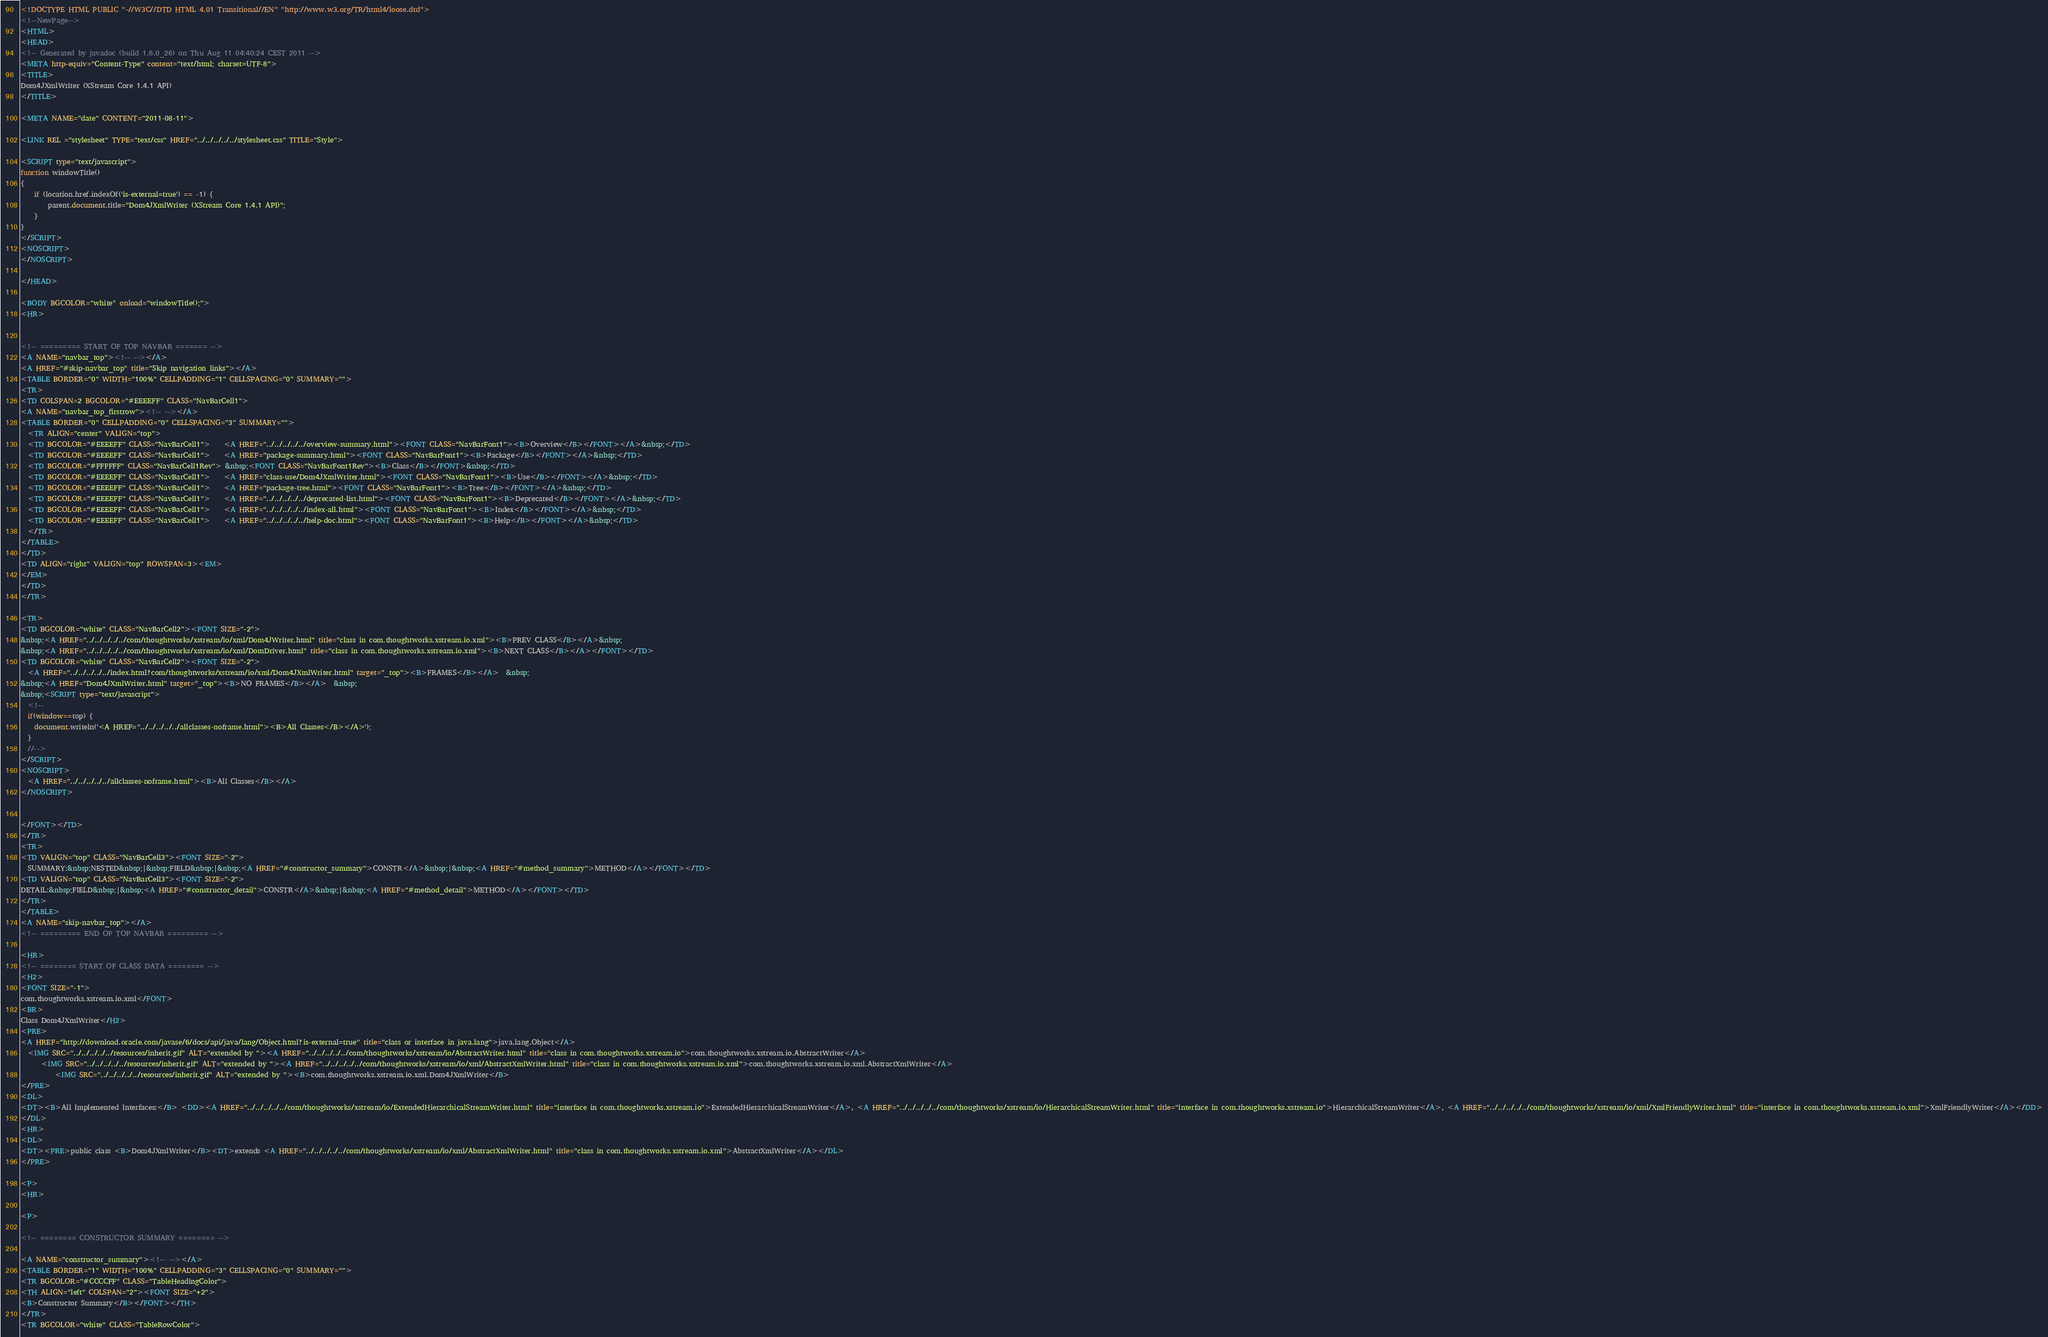Convert code to text. <code><loc_0><loc_0><loc_500><loc_500><_HTML_><!DOCTYPE HTML PUBLIC "-//W3C//DTD HTML 4.01 Transitional//EN" "http://www.w3.org/TR/html4/loose.dtd">
<!--NewPage-->
<HTML>
<HEAD>
<!-- Generated by javadoc (build 1.6.0_26) on Thu Aug 11 04:40:24 CEST 2011 -->
<META http-equiv="Content-Type" content="text/html; charset=UTF-8">
<TITLE>
Dom4JXmlWriter (XStream Core 1.4.1 API)
</TITLE>

<META NAME="date" CONTENT="2011-08-11">

<LINK REL ="stylesheet" TYPE="text/css" HREF="../../../../../stylesheet.css" TITLE="Style">

<SCRIPT type="text/javascript">
function windowTitle()
{
    if (location.href.indexOf('is-external=true') == -1) {
        parent.document.title="Dom4JXmlWriter (XStream Core 1.4.1 API)";
    }
}
</SCRIPT>
<NOSCRIPT>
</NOSCRIPT>

</HEAD>

<BODY BGCOLOR="white" onload="windowTitle();">
<HR>


<!-- ========= START OF TOP NAVBAR ======= -->
<A NAME="navbar_top"><!-- --></A>
<A HREF="#skip-navbar_top" title="Skip navigation links"></A>
<TABLE BORDER="0" WIDTH="100%" CELLPADDING="1" CELLSPACING="0" SUMMARY="">
<TR>
<TD COLSPAN=2 BGCOLOR="#EEEEFF" CLASS="NavBarCell1">
<A NAME="navbar_top_firstrow"><!-- --></A>
<TABLE BORDER="0" CELLPADDING="0" CELLSPACING="3" SUMMARY="">
  <TR ALIGN="center" VALIGN="top">
  <TD BGCOLOR="#EEEEFF" CLASS="NavBarCell1">    <A HREF="../../../../../overview-summary.html"><FONT CLASS="NavBarFont1"><B>Overview</B></FONT></A>&nbsp;</TD>
  <TD BGCOLOR="#EEEEFF" CLASS="NavBarCell1">    <A HREF="package-summary.html"><FONT CLASS="NavBarFont1"><B>Package</B></FONT></A>&nbsp;</TD>
  <TD BGCOLOR="#FFFFFF" CLASS="NavBarCell1Rev"> &nbsp;<FONT CLASS="NavBarFont1Rev"><B>Class</B></FONT>&nbsp;</TD>
  <TD BGCOLOR="#EEEEFF" CLASS="NavBarCell1">    <A HREF="class-use/Dom4JXmlWriter.html"><FONT CLASS="NavBarFont1"><B>Use</B></FONT></A>&nbsp;</TD>
  <TD BGCOLOR="#EEEEFF" CLASS="NavBarCell1">    <A HREF="package-tree.html"><FONT CLASS="NavBarFont1"><B>Tree</B></FONT></A>&nbsp;</TD>
  <TD BGCOLOR="#EEEEFF" CLASS="NavBarCell1">    <A HREF="../../../../../deprecated-list.html"><FONT CLASS="NavBarFont1"><B>Deprecated</B></FONT></A>&nbsp;</TD>
  <TD BGCOLOR="#EEEEFF" CLASS="NavBarCell1">    <A HREF="../../../../../index-all.html"><FONT CLASS="NavBarFont1"><B>Index</B></FONT></A>&nbsp;</TD>
  <TD BGCOLOR="#EEEEFF" CLASS="NavBarCell1">    <A HREF="../../../../../help-doc.html"><FONT CLASS="NavBarFont1"><B>Help</B></FONT></A>&nbsp;</TD>
  </TR>
</TABLE>
</TD>
<TD ALIGN="right" VALIGN="top" ROWSPAN=3><EM>
</EM>
</TD>
</TR>

<TR>
<TD BGCOLOR="white" CLASS="NavBarCell2"><FONT SIZE="-2">
&nbsp;<A HREF="../../../../../com/thoughtworks/xstream/io/xml/Dom4JWriter.html" title="class in com.thoughtworks.xstream.io.xml"><B>PREV CLASS</B></A>&nbsp;
&nbsp;<A HREF="../../../../../com/thoughtworks/xstream/io/xml/DomDriver.html" title="class in com.thoughtworks.xstream.io.xml"><B>NEXT CLASS</B></A></FONT></TD>
<TD BGCOLOR="white" CLASS="NavBarCell2"><FONT SIZE="-2">
  <A HREF="../../../../../index.html?com/thoughtworks/xstream/io/xml/Dom4JXmlWriter.html" target="_top"><B>FRAMES</B></A>  &nbsp;
&nbsp;<A HREF="Dom4JXmlWriter.html" target="_top"><B>NO FRAMES</B></A>  &nbsp;
&nbsp;<SCRIPT type="text/javascript">
  <!--
  if(window==top) {
    document.writeln('<A HREF="../../../../../allclasses-noframe.html"><B>All Classes</B></A>');
  }
  //-->
</SCRIPT>
<NOSCRIPT>
  <A HREF="../../../../../allclasses-noframe.html"><B>All Classes</B></A>
</NOSCRIPT>


</FONT></TD>
</TR>
<TR>
<TD VALIGN="top" CLASS="NavBarCell3"><FONT SIZE="-2">
  SUMMARY:&nbsp;NESTED&nbsp;|&nbsp;FIELD&nbsp;|&nbsp;<A HREF="#constructor_summary">CONSTR</A>&nbsp;|&nbsp;<A HREF="#method_summary">METHOD</A></FONT></TD>
<TD VALIGN="top" CLASS="NavBarCell3"><FONT SIZE="-2">
DETAIL:&nbsp;FIELD&nbsp;|&nbsp;<A HREF="#constructor_detail">CONSTR</A>&nbsp;|&nbsp;<A HREF="#method_detail">METHOD</A></FONT></TD>
</TR>
</TABLE>
<A NAME="skip-navbar_top"></A>
<!-- ========= END OF TOP NAVBAR ========= -->

<HR>
<!-- ======== START OF CLASS DATA ======== -->
<H2>
<FONT SIZE="-1">
com.thoughtworks.xstream.io.xml</FONT>
<BR>
Class Dom4JXmlWriter</H2>
<PRE>
<A HREF="http://download.oracle.com/javase/6/docs/api/java/lang/Object.html?is-external=true" title="class or interface in java.lang">java.lang.Object</A>
  <IMG SRC="../../../../../resources/inherit.gif" ALT="extended by "><A HREF="../../../../../com/thoughtworks/xstream/io/AbstractWriter.html" title="class in com.thoughtworks.xstream.io">com.thoughtworks.xstream.io.AbstractWriter</A>
      <IMG SRC="../../../../../resources/inherit.gif" ALT="extended by "><A HREF="../../../../../com/thoughtworks/xstream/io/xml/AbstractXmlWriter.html" title="class in com.thoughtworks.xstream.io.xml">com.thoughtworks.xstream.io.xml.AbstractXmlWriter</A>
          <IMG SRC="../../../../../resources/inherit.gif" ALT="extended by "><B>com.thoughtworks.xstream.io.xml.Dom4JXmlWriter</B>
</PRE>
<DL>
<DT><B>All Implemented Interfaces:</B> <DD><A HREF="../../../../../com/thoughtworks/xstream/io/ExtendedHierarchicalStreamWriter.html" title="interface in com.thoughtworks.xstream.io">ExtendedHierarchicalStreamWriter</A>, <A HREF="../../../../../com/thoughtworks/xstream/io/HierarchicalStreamWriter.html" title="interface in com.thoughtworks.xstream.io">HierarchicalStreamWriter</A>, <A HREF="../../../../../com/thoughtworks/xstream/io/xml/XmlFriendlyWriter.html" title="interface in com.thoughtworks.xstream.io.xml">XmlFriendlyWriter</A></DD>
</DL>
<HR>
<DL>
<DT><PRE>public class <B>Dom4JXmlWriter</B><DT>extends <A HREF="../../../../../com/thoughtworks/xstream/io/xml/AbstractXmlWriter.html" title="class in com.thoughtworks.xstream.io.xml">AbstractXmlWriter</A></DL>
</PRE>

<P>
<HR>

<P>

<!-- ======== CONSTRUCTOR SUMMARY ======== -->

<A NAME="constructor_summary"><!-- --></A>
<TABLE BORDER="1" WIDTH="100%" CELLPADDING="3" CELLSPACING="0" SUMMARY="">
<TR BGCOLOR="#CCCCFF" CLASS="TableHeadingColor">
<TH ALIGN="left" COLSPAN="2"><FONT SIZE="+2">
<B>Constructor Summary</B></FONT></TH>
</TR>
<TR BGCOLOR="white" CLASS="TableRowColor"></code> 